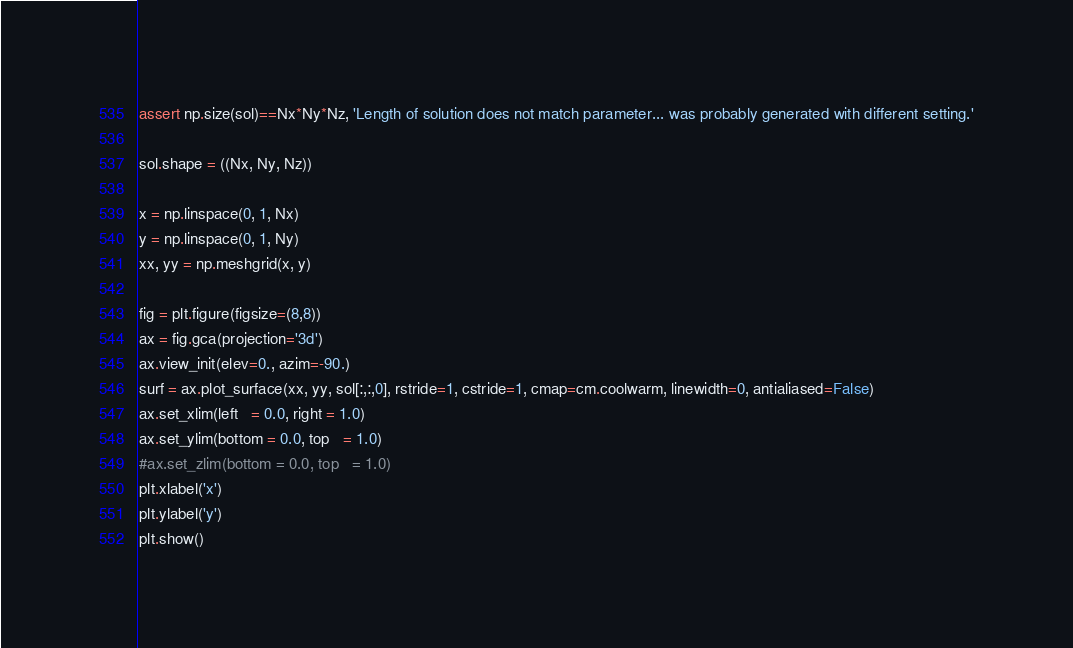Convert code to text. <code><loc_0><loc_0><loc_500><loc_500><_Python_>
assert np.size(sol)==Nx*Ny*Nz, 'Length of solution does not match parameter... was probably generated with different setting.'

sol.shape = ((Nx, Ny, Nz))

x = np.linspace(0, 1, Nx)
y = np.linspace(0, 1, Ny)
xx, yy = np.meshgrid(x, y)

fig = plt.figure(figsize=(8,8))
ax = fig.gca(projection='3d')
ax.view_init(elev=0., azim=-90.)
surf = ax.plot_surface(xx, yy, sol[:,:,0], rstride=1, cstride=1, cmap=cm.coolwarm, linewidth=0, antialiased=False)
ax.set_xlim(left   = 0.0, right = 1.0)
ax.set_ylim(bottom = 0.0, top   = 1.0)
#ax.set_zlim(bottom = 0.0, top   = 1.0)
plt.xlabel('x')
plt.ylabel('y')
plt.show()
</code> 